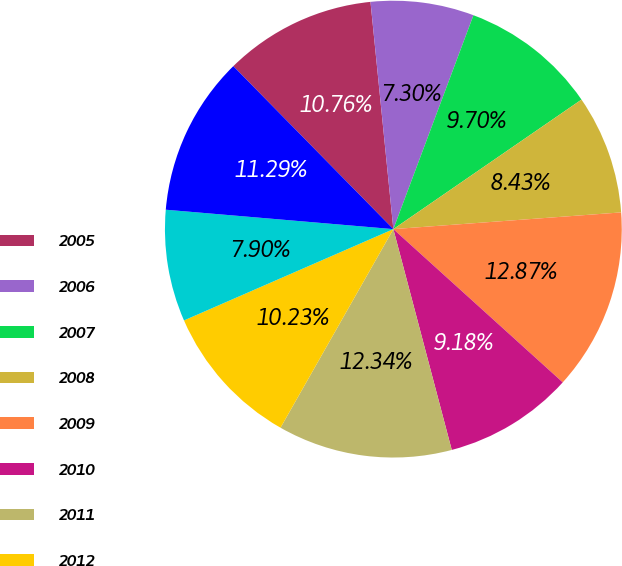Convert chart to OTSL. <chart><loc_0><loc_0><loc_500><loc_500><pie_chart><fcel>2005<fcel>2006<fcel>2007<fcel>2008<fcel>2009<fcel>2010<fcel>2011<fcel>2012<fcel>2013<fcel>2014<nl><fcel>10.76%<fcel>7.3%<fcel>9.7%<fcel>8.43%<fcel>12.87%<fcel>9.18%<fcel>12.34%<fcel>10.23%<fcel>7.9%<fcel>11.29%<nl></chart> 